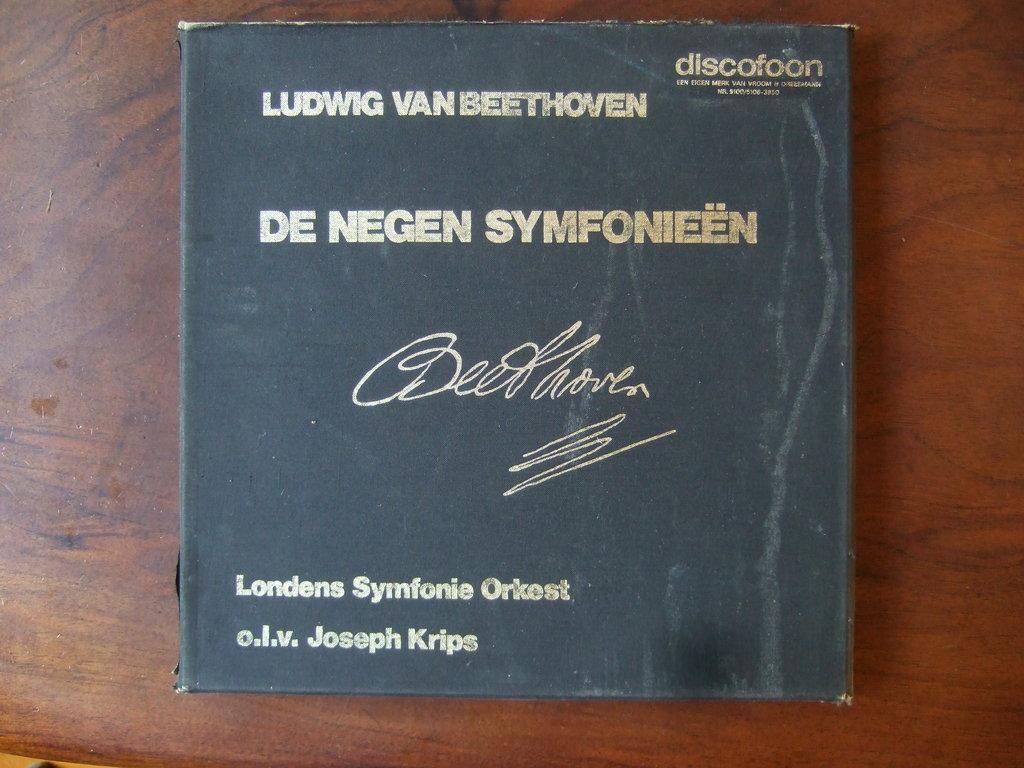Who signed this disc set?
Your response must be concise. Beethoven. Who performed the music?
Provide a short and direct response. Beethoven. 